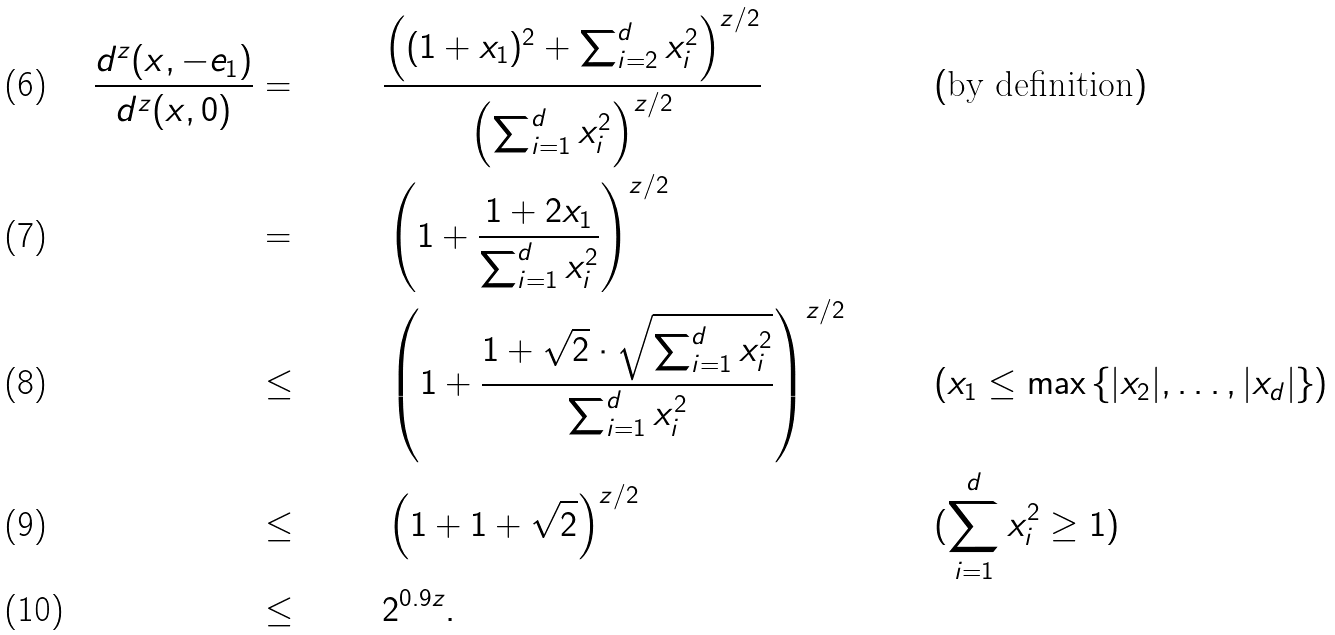Convert formula to latex. <formula><loc_0><loc_0><loc_500><loc_500>\frac { d ^ { z } ( x , - e _ { 1 } ) } { d ^ { z } ( x , 0 ) } & = & & \frac { \left ( ( 1 + x _ { 1 } ) ^ { 2 } + \sum _ { i = 2 } ^ { d } x _ { i } ^ { 2 } \right ) ^ { z / 2 } } { \left ( \sum _ { i = 1 } ^ { d } x _ { i } ^ { 2 } \right ) ^ { z / 2 } } & & ( \text {by definition} ) \\ & = & & \left ( 1 + \frac { 1 + 2 x _ { 1 } } { \sum _ { i = 1 } ^ { d } x _ { i } ^ { 2 } } \right ) ^ { z / 2 } & & \\ & \leq & & \left ( 1 + \frac { 1 + \sqrt { 2 } \cdot \sqrt { \sum _ { i = 1 } ^ { d } x _ { i } ^ { 2 } } } { \sum _ { i = 1 } ^ { d } x _ { i } ^ { 2 } } \right ) ^ { z / 2 } & & ( x _ { 1 } \leq \max \left \{ | x _ { 2 } | , \dots , | x _ { d } | \right \} ) \\ & \leq & & \left ( 1 + 1 + \sqrt { 2 } \right ) ^ { z / 2 } & & ( \sum _ { i = 1 } ^ { d } x _ { i } ^ { 2 } \geq 1 ) \\ & \leq & & 2 ^ { 0 . 9 z } . & &</formula> 